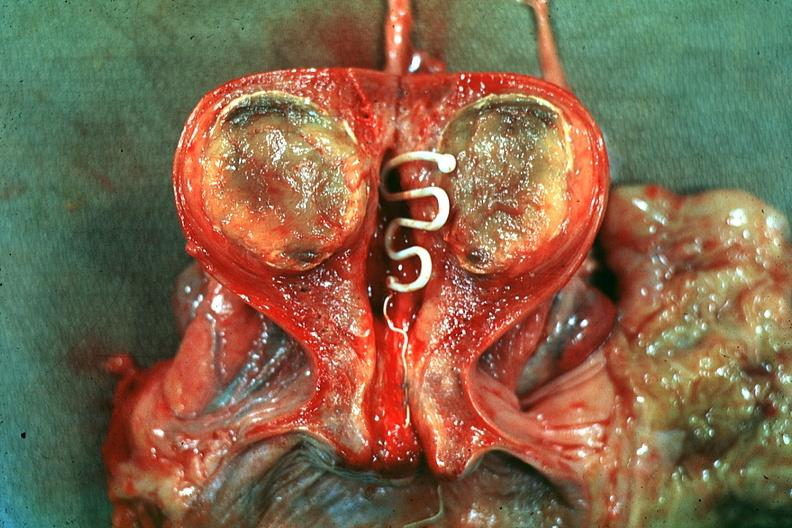s intrauterine contraceptive device present?
Answer the question using a single word or phrase. Yes 